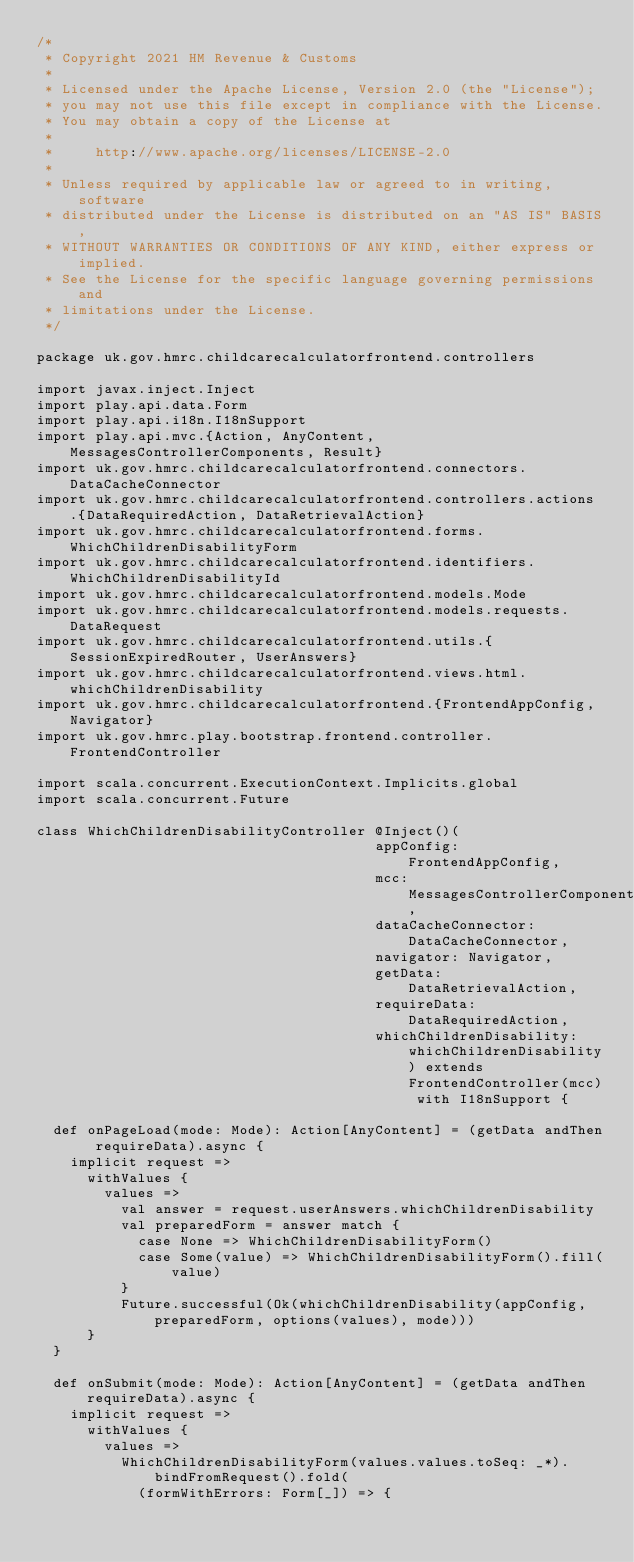<code> <loc_0><loc_0><loc_500><loc_500><_Scala_>/*
 * Copyright 2021 HM Revenue & Customs
 *
 * Licensed under the Apache License, Version 2.0 (the "License");
 * you may not use this file except in compliance with the License.
 * You may obtain a copy of the License at
 *
 *     http://www.apache.org/licenses/LICENSE-2.0
 *
 * Unless required by applicable law or agreed to in writing, software
 * distributed under the License is distributed on an "AS IS" BASIS,
 * WITHOUT WARRANTIES OR CONDITIONS OF ANY KIND, either express or implied.
 * See the License for the specific language governing permissions and
 * limitations under the License.
 */

package uk.gov.hmrc.childcarecalculatorfrontend.controllers

import javax.inject.Inject
import play.api.data.Form
import play.api.i18n.I18nSupport
import play.api.mvc.{Action, AnyContent, MessagesControllerComponents, Result}
import uk.gov.hmrc.childcarecalculatorfrontend.connectors.DataCacheConnector
import uk.gov.hmrc.childcarecalculatorfrontend.controllers.actions.{DataRequiredAction, DataRetrievalAction}
import uk.gov.hmrc.childcarecalculatorfrontend.forms.WhichChildrenDisabilityForm
import uk.gov.hmrc.childcarecalculatorfrontend.identifiers.WhichChildrenDisabilityId
import uk.gov.hmrc.childcarecalculatorfrontend.models.Mode
import uk.gov.hmrc.childcarecalculatorfrontend.models.requests.DataRequest
import uk.gov.hmrc.childcarecalculatorfrontend.utils.{SessionExpiredRouter, UserAnswers}
import uk.gov.hmrc.childcarecalculatorfrontend.views.html.whichChildrenDisability
import uk.gov.hmrc.childcarecalculatorfrontend.{FrontendAppConfig, Navigator}
import uk.gov.hmrc.play.bootstrap.frontend.controller.FrontendController

import scala.concurrent.ExecutionContext.Implicits.global
import scala.concurrent.Future

class WhichChildrenDisabilityController @Inject()(
                                        appConfig: FrontendAppConfig,
                                        mcc: MessagesControllerComponents,
                                        dataCacheConnector: DataCacheConnector,
                                        navigator: Navigator,
                                        getData: DataRetrievalAction,
                                        requireData: DataRequiredAction,
                                        whichChildrenDisability: whichChildrenDisability) extends FrontendController(mcc) with I18nSupport {

  def onPageLoad(mode: Mode): Action[AnyContent] = (getData andThen requireData).async {
    implicit request =>
      withValues {
        values =>
          val answer = request.userAnswers.whichChildrenDisability
          val preparedForm = answer match {
            case None => WhichChildrenDisabilityForm()
            case Some(value) => WhichChildrenDisabilityForm().fill(value)
          }
          Future.successful(Ok(whichChildrenDisability(appConfig, preparedForm, options(values), mode)))
      }
  }

  def onSubmit(mode: Mode): Action[AnyContent] = (getData andThen requireData).async {
    implicit request =>
      withValues {
        values =>
          WhichChildrenDisabilityForm(values.values.toSeq: _*).bindFromRequest().fold(
            (formWithErrors: Form[_]) => {</code> 